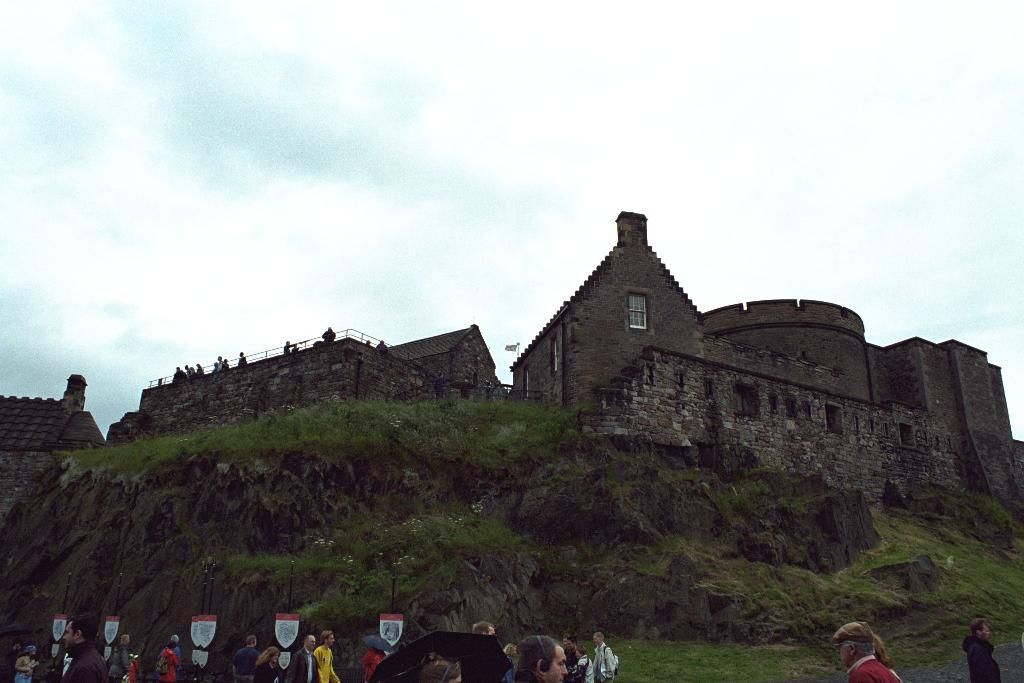What type of structure is in the image? There is a fort in the image. Where is the fort located? The fort is on a grass hill. What can be seen around the fort? The fort is surrounded by greenery. Are there any people visible in the image? Yes, there are people standing at the bottom of the hill. What type of popcorn is being served at the competition in the image? There is no competition or popcorn present in the image; it features a fort on a grass hill with people standing at the bottom. 